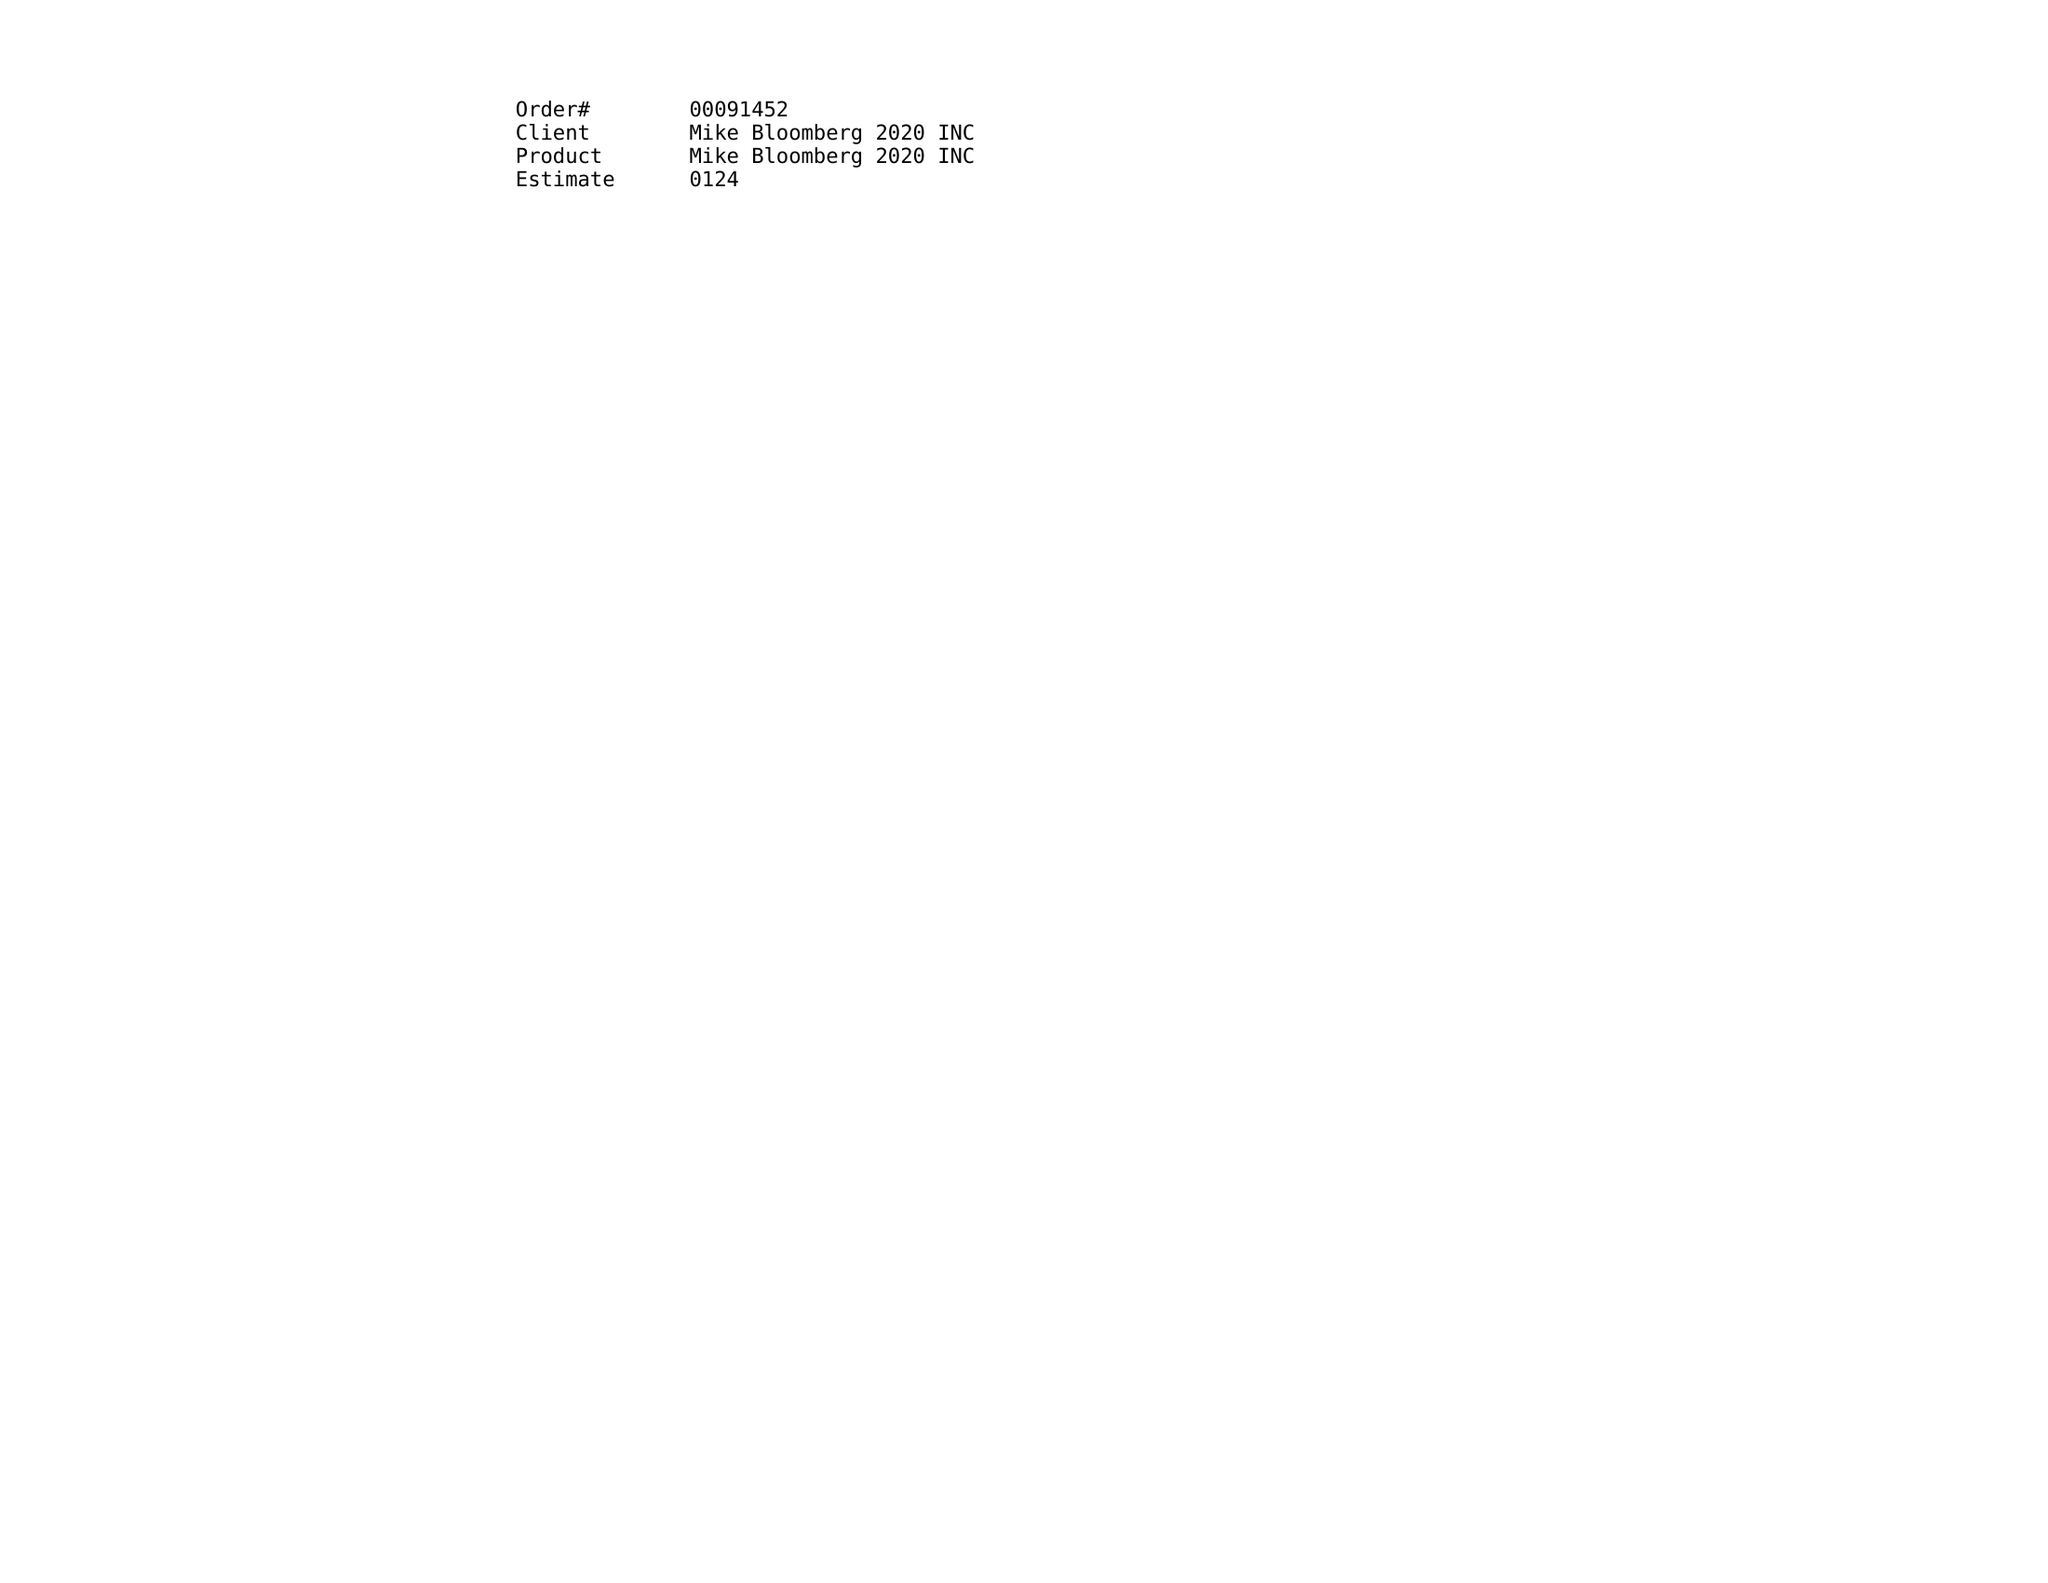What is the value for the contract_num?
Answer the question using a single word or phrase. 00091452 